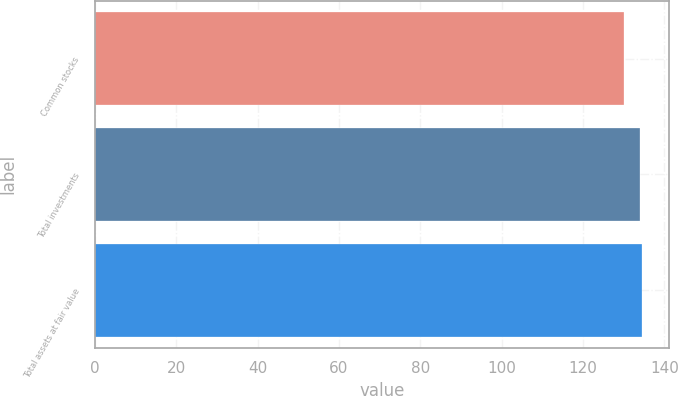Convert chart. <chart><loc_0><loc_0><loc_500><loc_500><bar_chart><fcel>Common stocks<fcel>Total investments<fcel>Total assets at fair value<nl><fcel>130<fcel>134<fcel>134.4<nl></chart> 